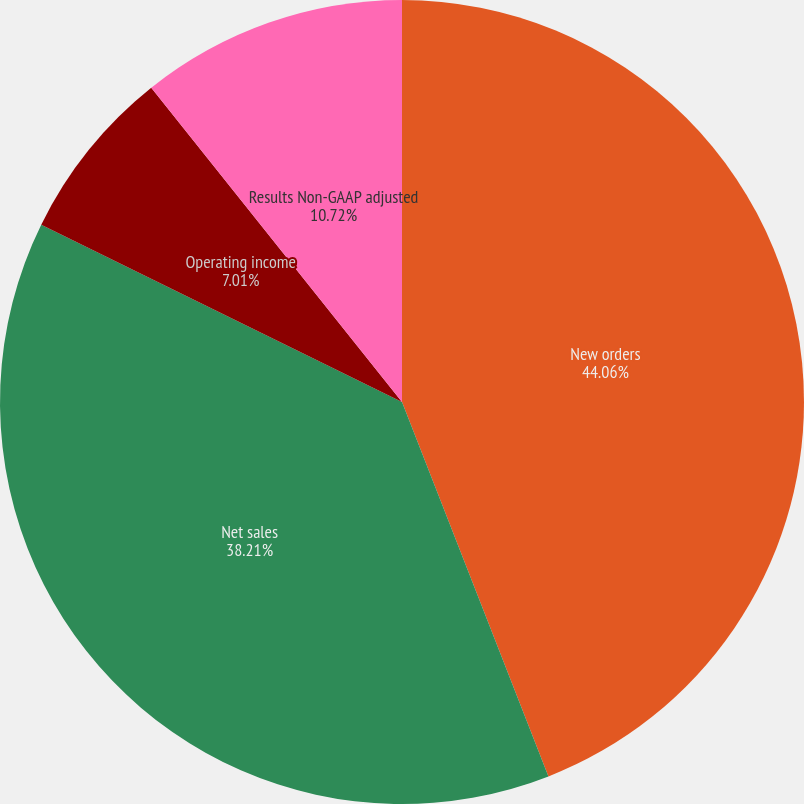Convert chart. <chart><loc_0><loc_0><loc_500><loc_500><pie_chart><fcel>New orders<fcel>Net sales<fcel>Operating income<fcel>Results Non-GAAP adjusted<nl><fcel>44.07%<fcel>38.21%<fcel>7.01%<fcel>10.72%<nl></chart> 